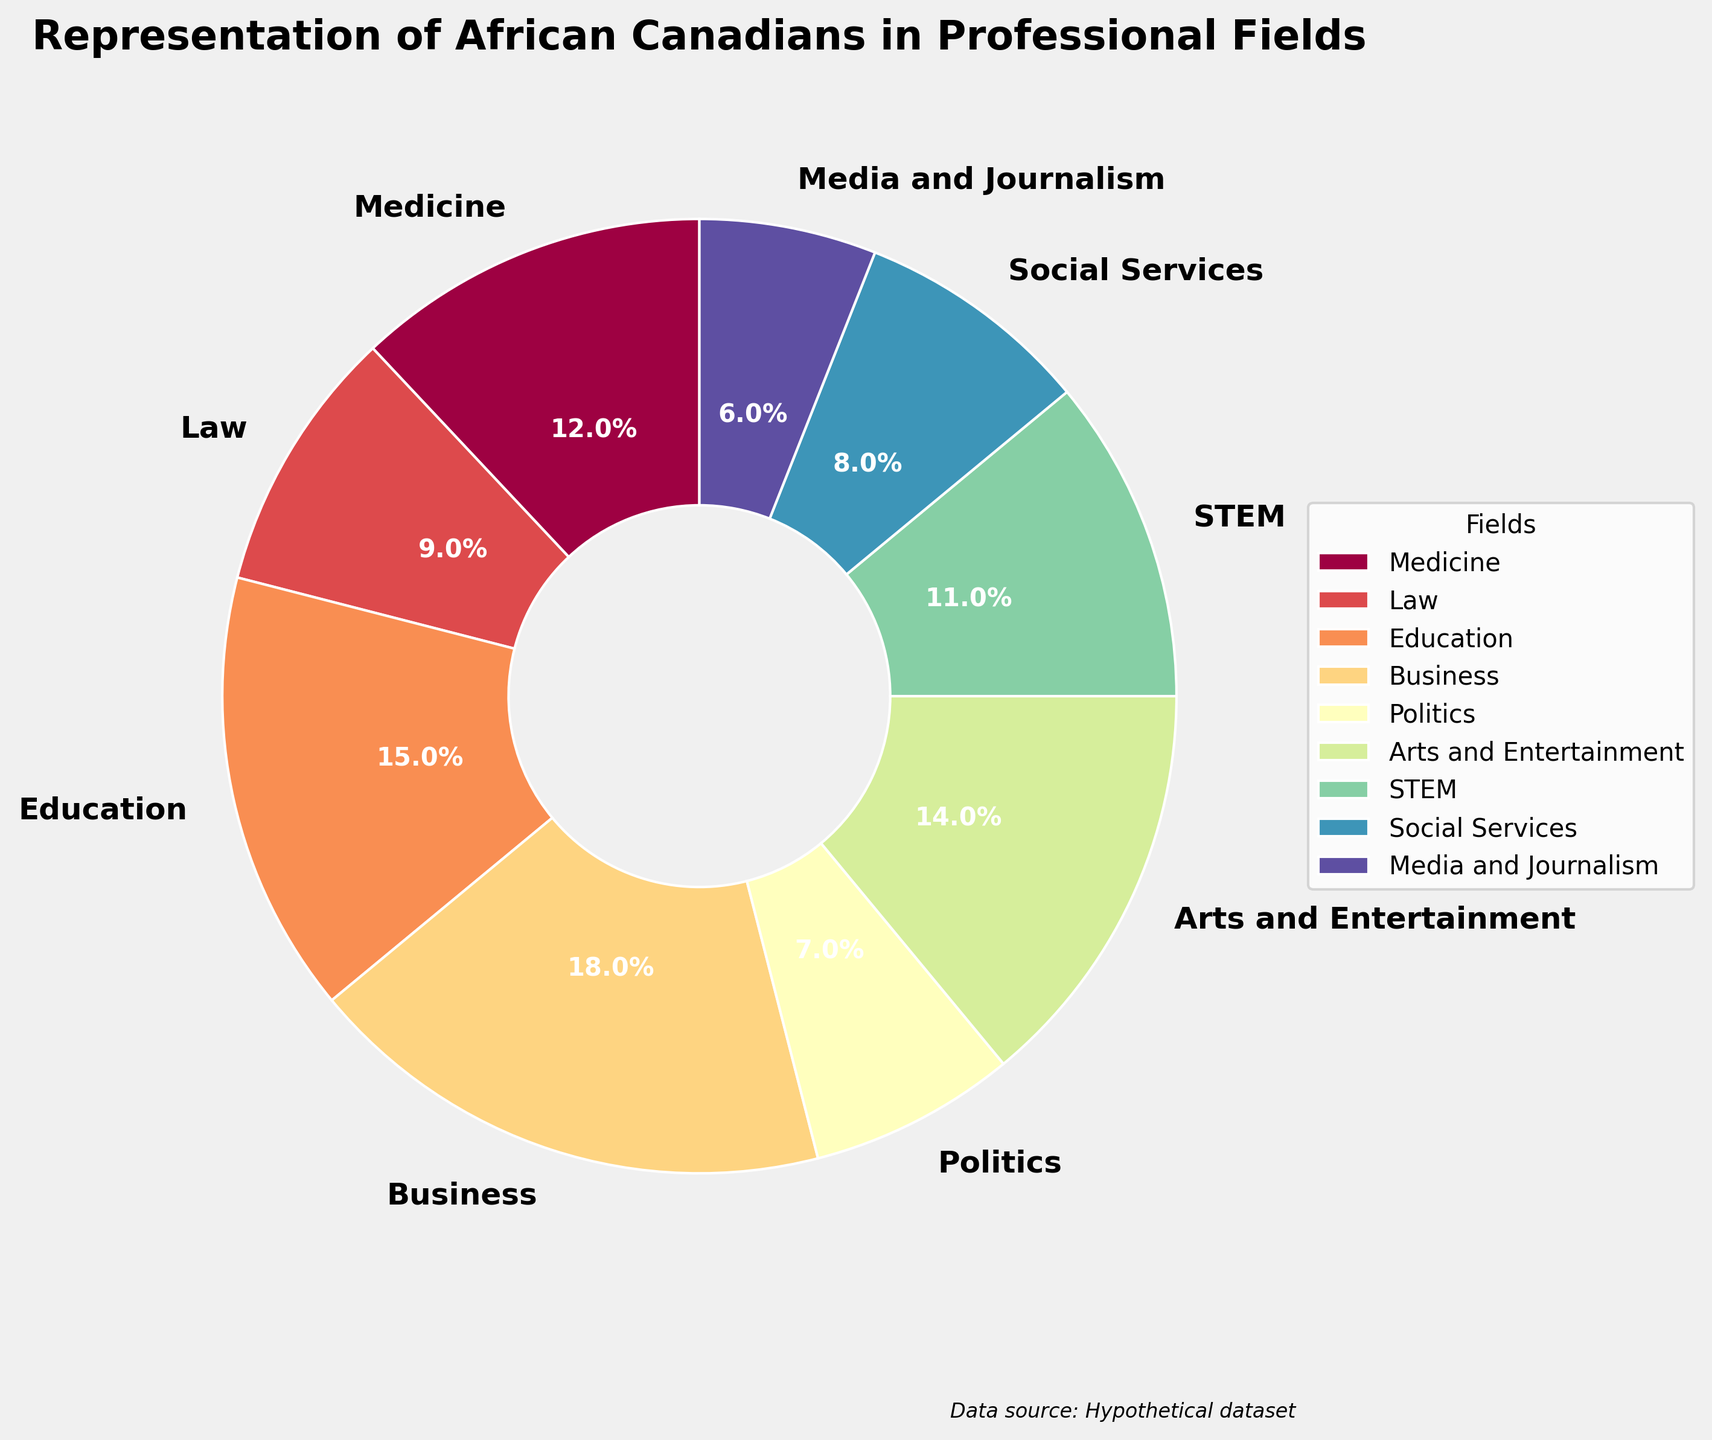What is the title of the figure? The title is usually placed at the top of the figure, and it describes what the chart represents.
Answer: Representation of African Canadians in Professional Fields Which professional field has the highest representation of African Canadians? By looking at the percentage labels on the pie chart, identify the largest segment.
Answer: Business How much more representation does the field of Education have compared to Social Services? Look at the percentages for both fields and subtract the smaller percentage from the larger one. (Education: 15%, Social Services: 8%)
Answer: 7% Which field has the least representation, and what is its percentage? Identify the smallest segment in the pie chart and read off its percentage.
Answer: Media and Journalism, 6% What is the combined percentage for Medicine and STEM fields? Add the percentages of Medicine (12%) and STEM (11%) together.
Answer: 23% Compare the representation of Arts and Entertainment with Law. Look at the pie chart to identify both fields and compare their percentages. (Arts and Entertainment: 14%, Law: 9%)
Answer: Arts and Entertainment has 5% more representation than Law How many professional fields have a representation percentage of 10% or more? Count the number of segments in the pie chart that have a percentage label of 10% or above.
Answer: 5 If you sum up the percentages of Business, Law, and Politics, what do you get? Add the percentages of Business (18%), Law (9%), and Politics (7%).
Answer: 34% Which two fields combined make up exactly one quarter (25%) representation? Look for two segments in the pie chart whose percentages add up to 25%. (Social Services: 8%, STEM: 11%, Arts and Entertainment: 14%, Media and Journalism: 6%, Law: 9%)
Answer: Law and Politics What is the average representation percentage across all the professional fields shown? Add all the percentages together and divide by the number of fields (9). (12+9+15+18+7+14+11+8+6 = 100%, 100/9)
Answer: 11.11% 